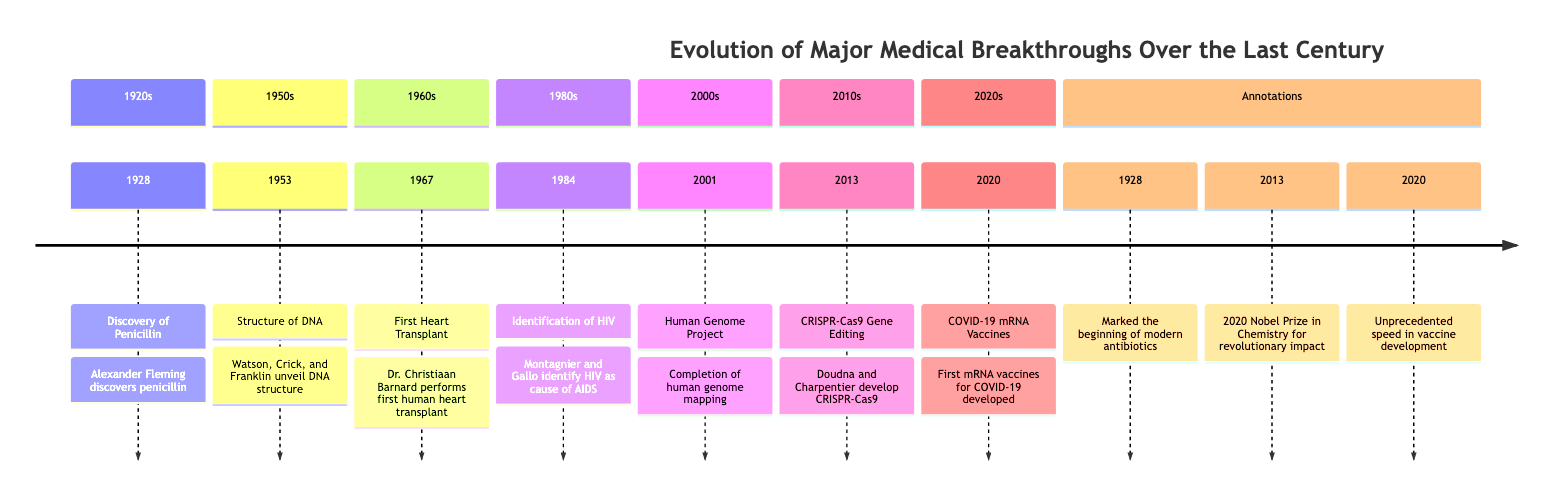What year was penicillin discovered? The diagram shows that penicillin was discovered in the year 1928. This is labeled as a significant event on the timeline.
Answer: 1928 Who discovered the structure of DNA? According to the timeline, the structure of DNA was unveiled by Watson, Crick, and Franklin in 1953. Their names are mentioned alongside this event.
Answer: Watson, Crick, and Franklin What milestone event occurred in 1967? The diagram highlights that in 1967, the first human heart transplant took place. This event is marked clearly on the timeline.
Answer: First Heart Transplant How many major breakthroughs are listed in the timeline? By counting the events shown on the timeline, there are a total of seven major breakthroughs listed, which are represented by distinct markers.
Answer: 7 Which event spurred global research on HIV/AIDS? The timeline indicates that the identification of HIV in 1984 sparked global research and the development of antiretroviral therapies. This is directly noted in the event’s description.
Answer: Identification of HIV What significant medical breakthrough was completed in 2001? In 2001, the Human Genome Project, which successfully mapped the entire human genome, is marked as a major medical breakthrough. This information is specific to that year on the timeline.
Answer: Completion of Human Genome Project What did CRISPR-Cas9 enable in genetic research? The annotation under the 2013 event states that CRISPR-Cas9 opened new avenues in genetic research, which highlights its revolutionary impact.
Answer: New avenues in genetic research What trend was established due to the COVID-19 vaccines developed in 2020? The timeline notes that the COVID-19 mRNA vaccines established a new platform for rapid vaccine development, which related to the response in the COVID-19 pandemic.
Answer: New platform for rapid vaccine development 